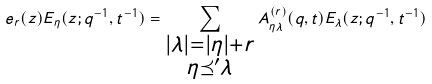<formula> <loc_0><loc_0><loc_500><loc_500>e _ { r } ( z ) E _ { \eta } ( z ; q ^ { - 1 } , t ^ { - 1 } ) = \sum _ { \substack { | \lambda | = | \eta | + r \\ \eta \preceq ^ { \prime } \lambda } } A _ { \eta \lambda } ^ { ( r ) } ( q , t ) E _ { \lambda } ( z ; q ^ { - 1 } , t ^ { - 1 } )</formula> 